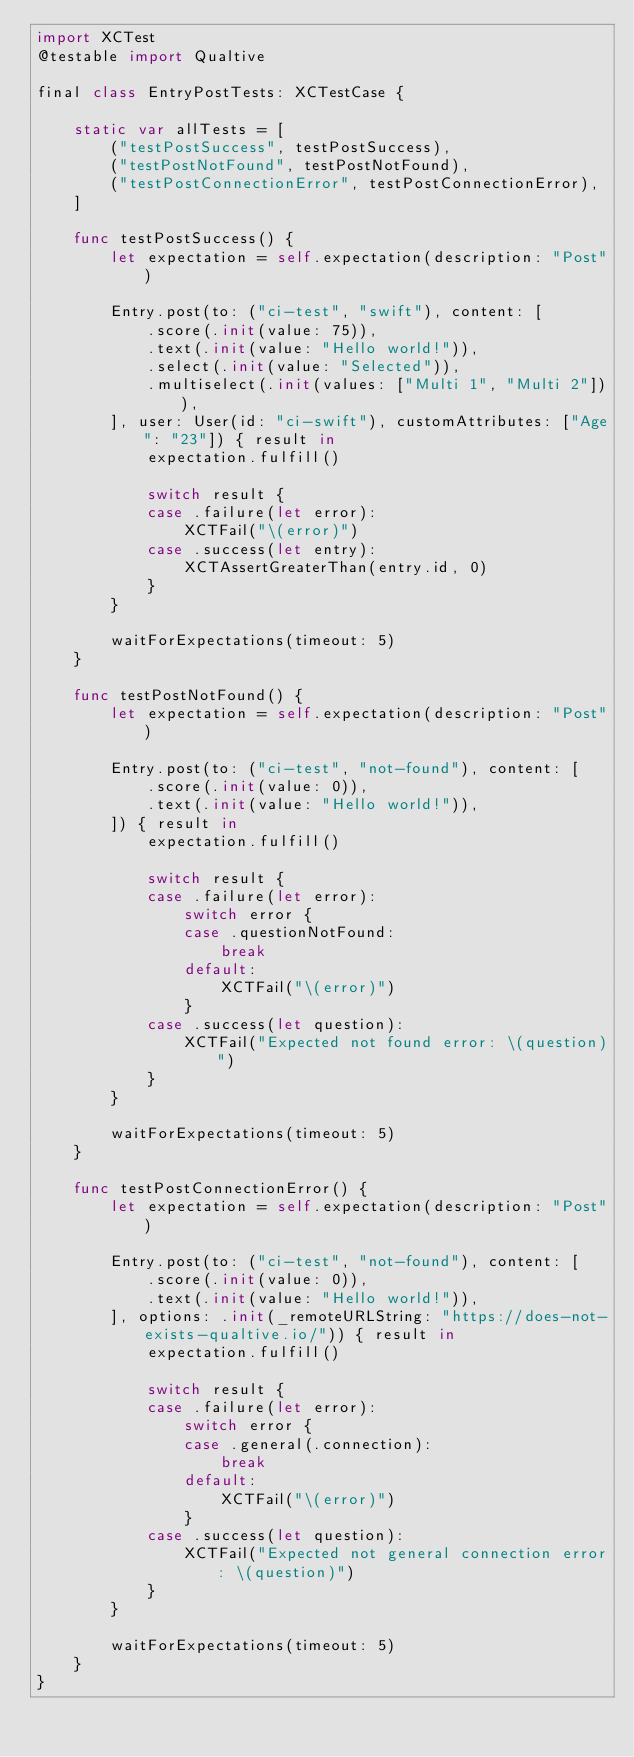Convert code to text. <code><loc_0><loc_0><loc_500><loc_500><_Swift_>import XCTest
@testable import Qualtive

final class EntryPostTests: XCTestCase {

    static var allTests = [
        ("testPostSuccess", testPostSuccess),
        ("testPostNotFound", testPostNotFound),
        ("testPostConnectionError", testPostConnectionError),
    ]

    func testPostSuccess() {
        let expectation = self.expectation(description: "Post")

        Entry.post(to: ("ci-test", "swift"), content: [
            .score(.init(value: 75)),
            .text(.init(value: "Hello world!")),
            .select(.init(value: "Selected")),
            .multiselect(.init(values: ["Multi 1", "Multi 2"])),
        ], user: User(id: "ci-swift"), customAttributes: ["Age": "23"]) { result in
            expectation.fulfill()

            switch result {
            case .failure(let error):
                XCTFail("\(error)")
            case .success(let entry):
                XCTAssertGreaterThan(entry.id, 0)
            }
        }

        waitForExpectations(timeout: 5)
    }

    func testPostNotFound() {
        let expectation = self.expectation(description: "Post")

        Entry.post(to: ("ci-test", "not-found"), content: [
            .score(.init(value: 0)),
            .text(.init(value: "Hello world!")),
        ]) { result in
            expectation.fulfill()

            switch result {
            case .failure(let error):
                switch error {
                case .questionNotFound:
                    break
                default:
                    XCTFail("\(error)")
                }
            case .success(let question):
                XCTFail("Expected not found error: \(question)")
            }
        }

        waitForExpectations(timeout: 5)
    }

    func testPostConnectionError() {
        let expectation = self.expectation(description: "Post")

        Entry.post(to: ("ci-test", "not-found"), content: [
            .score(.init(value: 0)),
            .text(.init(value: "Hello world!")),
        ], options: .init(_remoteURLString: "https://does-not-exists-qualtive.io/")) { result in
            expectation.fulfill()

            switch result {
            case .failure(let error):
                switch error {
                case .general(.connection):
                    break
                default:
                    XCTFail("\(error)")
                }
            case .success(let question):
                XCTFail("Expected not general connection error: \(question)")
            }
        }

        waitForExpectations(timeout: 5)
    }
}
</code> 